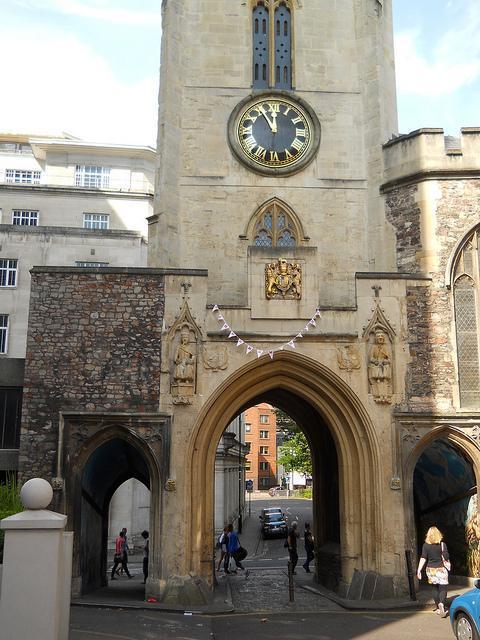What numeral system is used on the clock?
Pick the correct solution from the four options below to address the question.
Options: Egyptian, greek, roman, digital. Roman. 